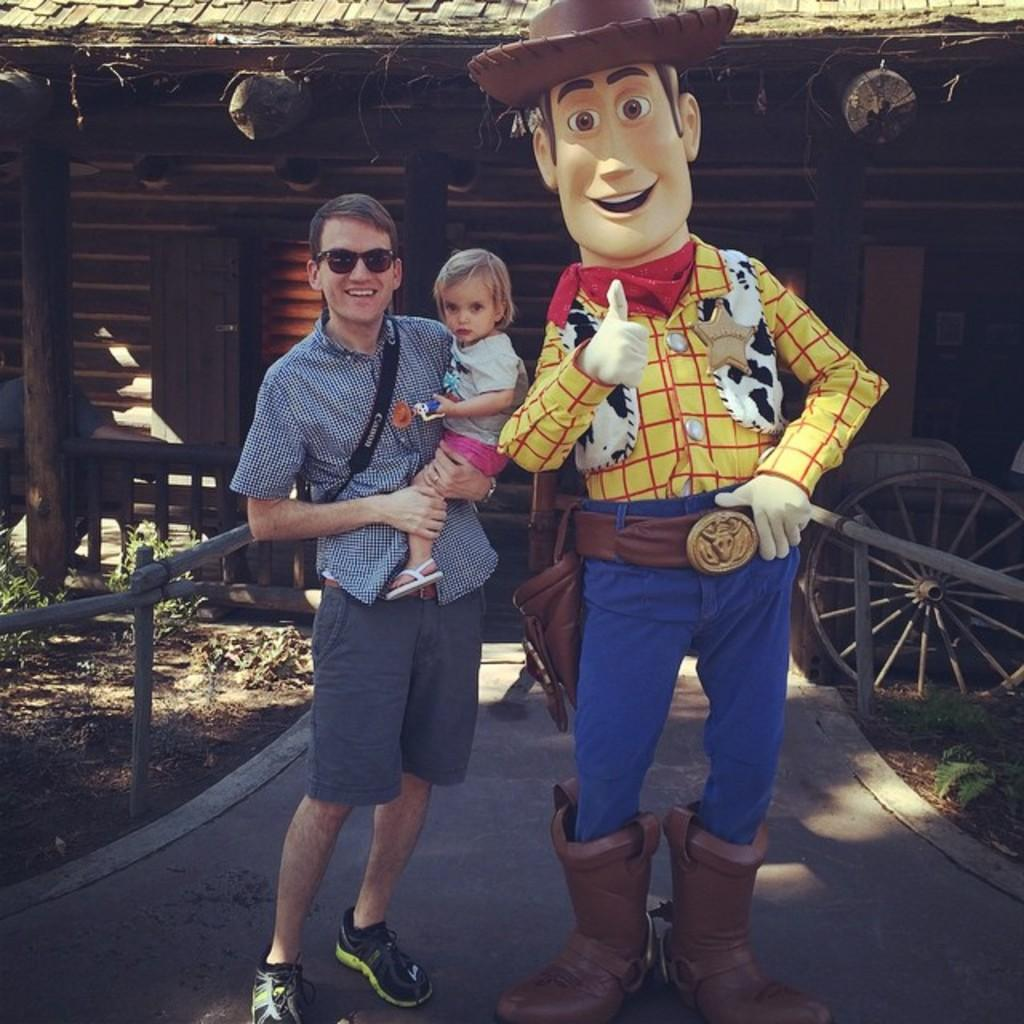What is the main action taking place in the image? There is a person carrying a child in the image. What can be seen in the background of the image? There is a shed in the background of the image. What type of sound can be heard coming from the egg in the image? There is no egg present in the image, so it is not possible to determine what, if any, sound might be heard. 